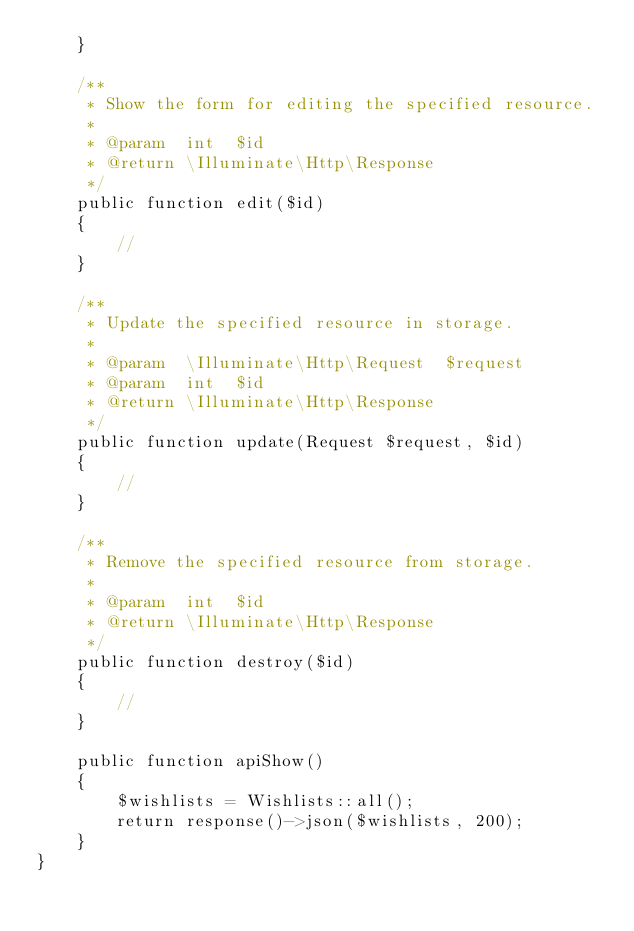Convert code to text. <code><loc_0><loc_0><loc_500><loc_500><_PHP_>    }

    /**
     * Show the form for editing the specified resource.
     *
     * @param  int  $id
     * @return \Illuminate\Http\Response
     */
    public function edit($id)
    {
        //
    }

    /**
     * Update the specified resource in storage.
     *
     * @param  \Illuminate\Http\Request  $request
     * @param  int  $id
     * @return \Illuminate\Http\Response
     */
    public function update(Request $request, $id)
    {
        //
    }

    /**
     * Remove the specified resource from storage.
     *
     * @param  int  $id
     * @return \Illuminate\Http\Response
     */
    public function destroy($id)
    {
        //
    }
   
    public function apiShow()
    {
        $wishlists = Wishlists::all();
        return response()->json($wishlists, 200);
    }
}</code> 